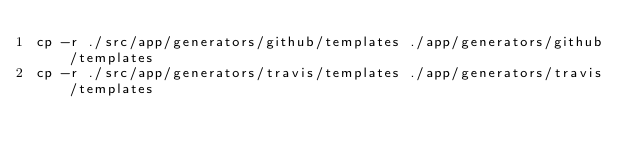<code> <loc_0><loc_0><loc_500><loc_500><_Bash_>cp -r ./src/app/generators/github/templates ./app/generators/github/templates
cp -r ./src/app/generators/travis/templates ./app/generators/travis/templates
</code> 